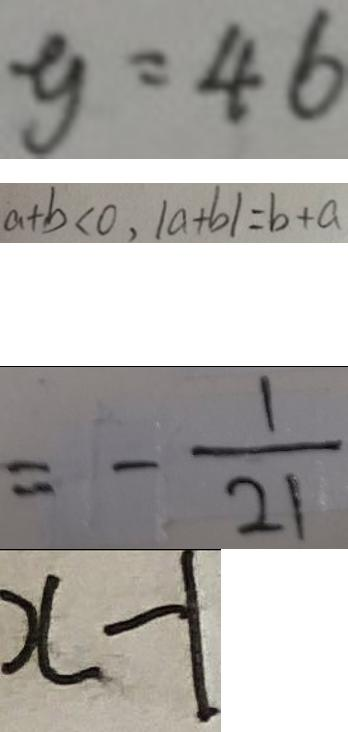<formula> <loc_0><loc_0><loc_500><loc_500>y = 4 6 
 a + b < 0 , \vert a + b \vert = b + a 
 = - \frac { 1 } { 2 1 } 
 x - 1</formula> 